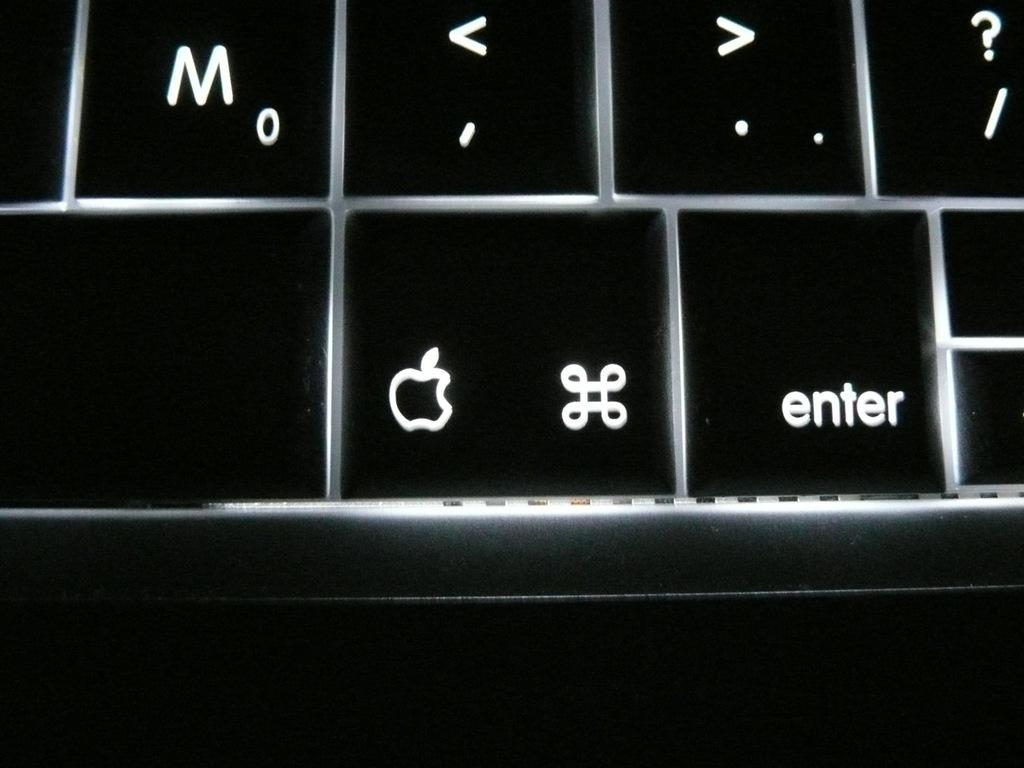<image>
Write a terse but informative summary of the picture. The apple and enter key on a computer keyboard. 